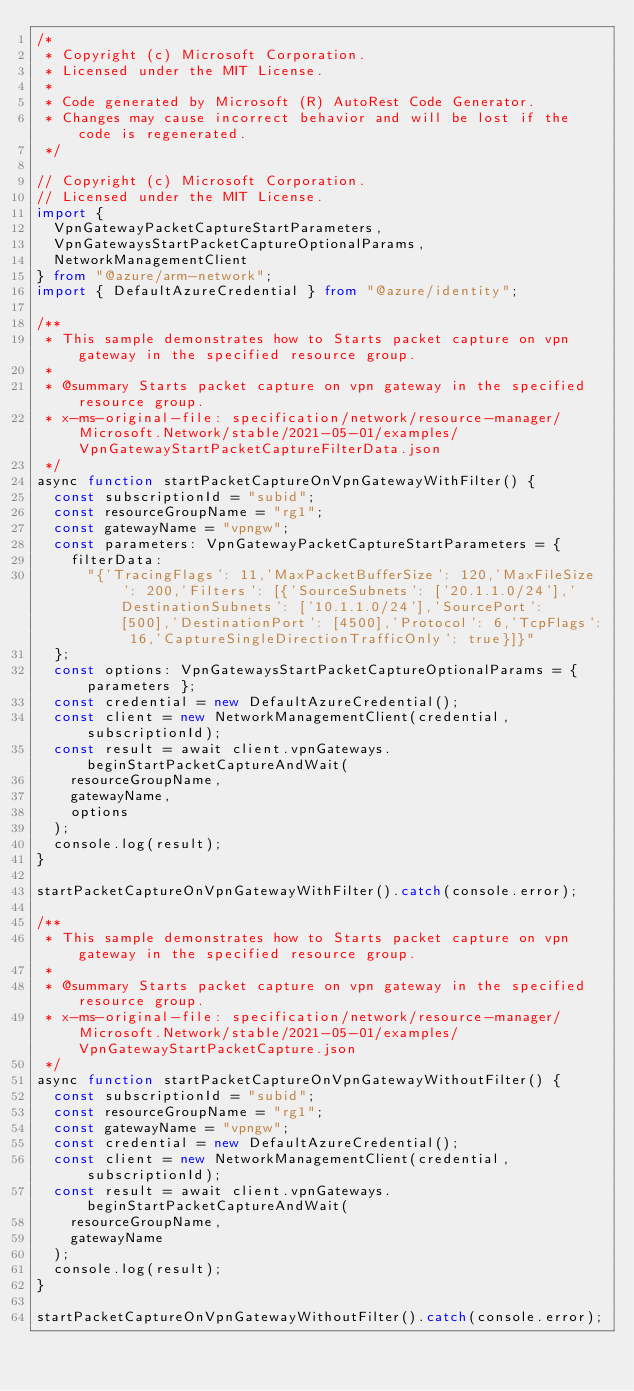Convert code to text. <code><loc_0><loc_0><loc_500><loc_500><_TypeScript_>/*
 * Copyright (c) Microsoft Corporation.
 * Licensed under the MIT License.
 *
 * Code generated by Microsoft (R) AutoRest Code Generator.
 * Changes may cause incorrect behavior and will be lost if the code is regenerated.
 */

// Copyright (c) Microsoft Corporation.
// Licensed under the MIT License.
import {
  VpnGatewayPacketCaptureStartParameters,
  VpnGatewaysStartPacketCaptureOptionalParams,
  NetworkManagementClient
} from "@azure/arm-network";
import { DefaultAzureCredential } from "@azure/identity";

/**
 * This sample demonstrates how to Starts packet capture on vpn gateway in the specified resource group.
 *
 * @summary Starts packet capture on vpn gateway in the specified resource group.
 * x-ms-original-file: specification/network/resource-manager/Microsoft.Network/stable/2021-05-01/examples/VpnGatewayStartPacketCaptureFilterData.json
 */
async function startPacketCaptureOnVpnGatewayWithFilter() {
  const subscriptionId = "subid";
  const resourceGroupName = "rg1";
  const gatewayName = "vpngw";
  const parameters: VpnGatewayPacketCaptureStartParameters = {
    filterData:
      "{'TracingFlags': 11,'MaxPacketBufferSize': 120,'MaxFileSize': 200,'Filters': [{'SourceSubnets': ['20.1.1.0/24'],'DestinationSubnets': ['10.1.1.0/24'],'SourcePort': [500],'DestinationPort': [4500],'Protocol': 6,'TcpFlags': 16,'CaptureSingleDirectionTrafficOnly': true}]}"
  };
  const options: VpnGatewaysStartPacketCaptureOptionalParams = { parameters };
  const credential = new DefaultAzureCredential();
  const client = new NetworkManagementClient(credential, subscriptionId);
  const result = await client.vpnGateways.beginStartPacketCaptureAndWait(
    resourceGroupName,
    gatewayName,
    options
  );
  console.log(result);
}

startPacketCaptureOnVpnGatewayWithFilter().catch(console.error);

/**
 * This sample demonstrates how to Starts packet capture on vpn gateway in the specified resource group.
 *
 * @summary Starts packet capture on vpn gateway in the specified resource group.
 * x-ms-original-file: specification/network/resource-manager/Microsoft.Network/stable/2021-05-01/examples/VpnGatewayStartPacketCapture.json
 */
async function startPacketCaptureOnVpnGatewayWithoutFilter() {
  const subscriptionId = "subid";
  const resourceGroupName = "rg1";
  const gatewayName = "vpngw";
  const credential = new DefaultAzureCredential();
  const client = new NetworkManagementClient(credential, subscriptionId);
  const result = await client.vpnGateways.beginStartPacketCaptureAndWait(
    resourceGroupName,
    gatewayName
  );
  console.log(result);
}

startPacketCaptureOnVpnGatewayWithoutFilter().catch(console.error);
</code> 